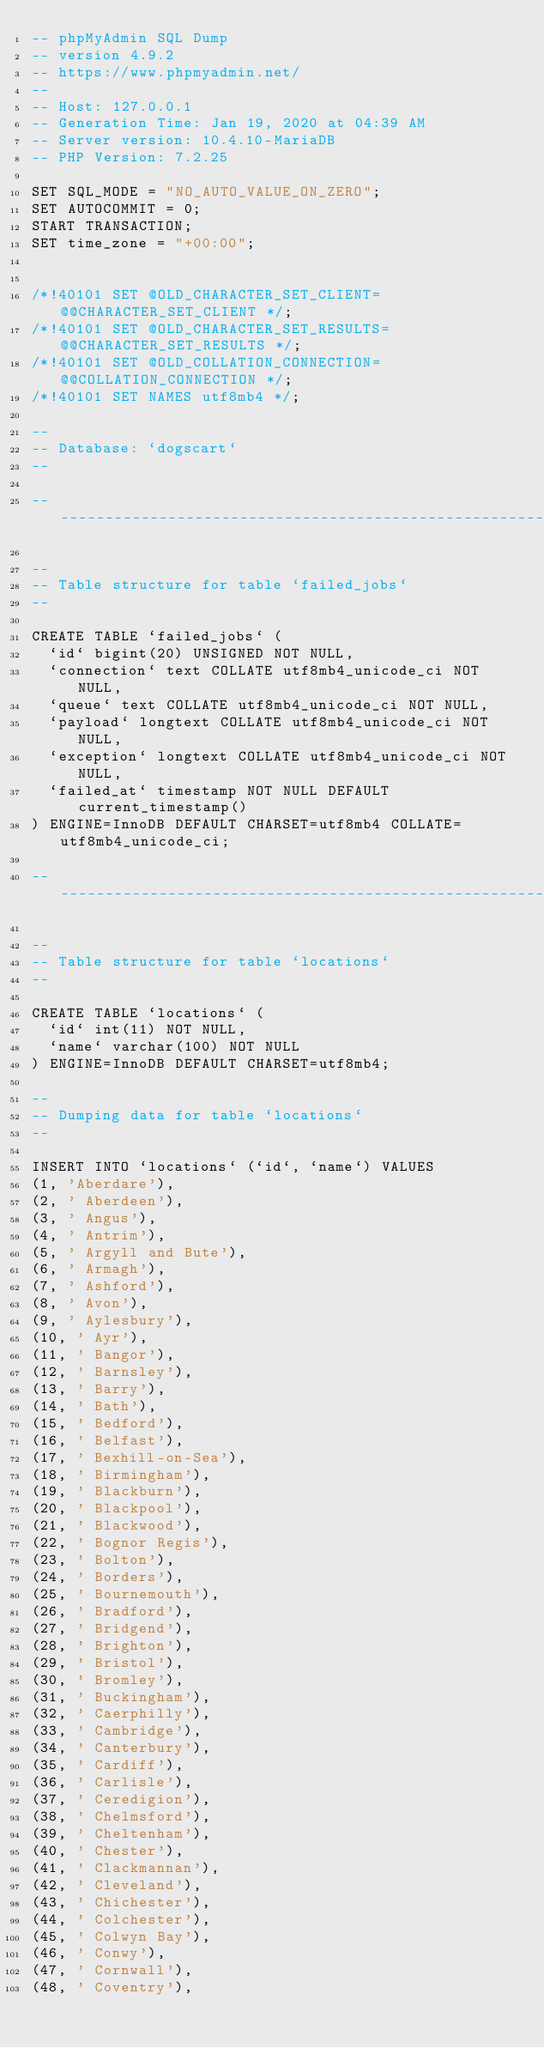<code> <loc_0><loc_0><loc_500><loc_500><_SQL_>-- phpMyAdmin SQL Dump
-- version 4.9.2
-- https://www.phpmyadmin.net/
--
-- Host: 127.0.0.1
-- Generation Time: Jan 19, 2020 at 04:39 AM
-- Server version: 10.4.10-MariaDB
-- PHP Version: 7.2.25

SET SQL_MODE = "NO_AUTO_VALUE_ON_ZERO";
SET AUTOCOMMIT = 0;
START TRANSACTION;
SET time_zone = "+00:00";


/*!40101 SET @OLD_CHARACTER_SET_CLIENT=@@CHARACTER_SET_CLIENT */;
/*!40101 SET @OLD_CHARACTER_SET_RESULTS=@@CHARACTER_SET_RESULTS */;
/*!40101 SET @OLD_COLLATION_CONNECTION=@@COLLATION_CONNECTION */;
/*!40101 SET NAMES utf8mb4 */;

--
-- Database: `dogscart`
--

-- --------------------------------------------------------

--
-- Table structure for table `failed_jobs`
--

CREATE TABLE `failed_jobs` (
  `id` bigint(20) UNSIGNED NOT NULL,
  `connection` text COLLATE utf8mb4_unicode_ci NOT NULL,
  `queue` text COLLATE utf8mb4_unicode_ci NOT NULL,
  `payload` longtext COLLATE utf8mb4_unicode_ci NOT NULL,
  `exception` longtext COLLATE utf8mb4_unicode_ci NOT NULL,
  `failed_at` timestamp NOT NULL DEFAULT current_timestamp()
) ENGINE=InnoDB DEFAULT CHARSET=utf8mb4 COLLATE=utf8mb4_unicode_ci;

-- --------------------------------------------------------

--
-- Table structure for table `locations`
--

CREATE TABLE `locations` (
  `id` int(11) NOT NULL,
  `name` varchar(100) NOT NULL
) ENGINE=InnoDB DEFAULT CHARSET=utf8mb4;

--
-- Dumping data for table `locations`
--

INSERT INTO `locations` (`id`, `name`) VALUES
(1, 'Aberdare'),
(2, ' Aberdeen'),
(3, ' Angus'),
(4, ' Antrim'),
(5, ' Argyll and Bute'),
(6, ' Armagh'),
(7, ' Ashford'),
(8, ' Avon'),
(9, ' Aylesbury'),
(10, ' Ayr'),
(11, ' Bangor'),
(12, ' Barnsley'),
(13, ' Barry'),
(14, ' Bath'),
(15, ' Bedford'),
(16, ' Belfast'),
(17, ' Bexhill-on-Sea'),
(18, ' Birmingham'),
(19, ' Blackburn'),
(20, ' Blackpool'),
(21, ' Blackwood'),
(22, ' Bognor Regis'),
(23, ' Bolton'),
(24, ' Borders'),
(25, ' Bournemouth'),
(26, ' Bradford'),
(27, ' Bridgend'),
(28, ' Brighton'),
(29, ' Bristol'),
(30, ' Bromley'),
(31, ' Buckingham'),
(32, ' Caerphilly'),
(33, ' Cambridge'),
(34, ' Canterbury'),
(35, ' Cardiff'),
(36, ' Carlisle'),
(37, ' Ceredigion'),
(38, ' Chelmsford'),
(39, ' Cheltenham'),
(40, ' Chester'),
(41, ' Clackmannan'),
(42, ' Cleveland'),
(43, ' Chichester'),
(44, ' Colchester'),
(45, ' Colwyn Bay'),
(46, ' Conwy'),
(47, ' Cornwall'),
(48, ' Coventry'),</code> 